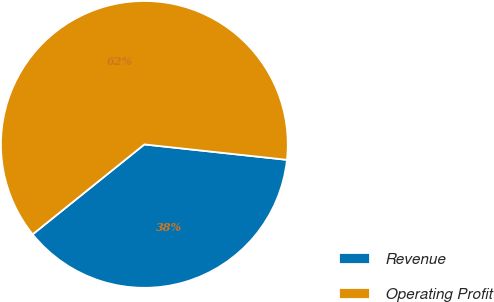<chart> <loc_0><loc_0><loc_500><loc_500><pie_chart><fcel>Revenue<fcel>Operating Profit<nl><fcel>37.5%<fcel>62.5%<nl></chart> 